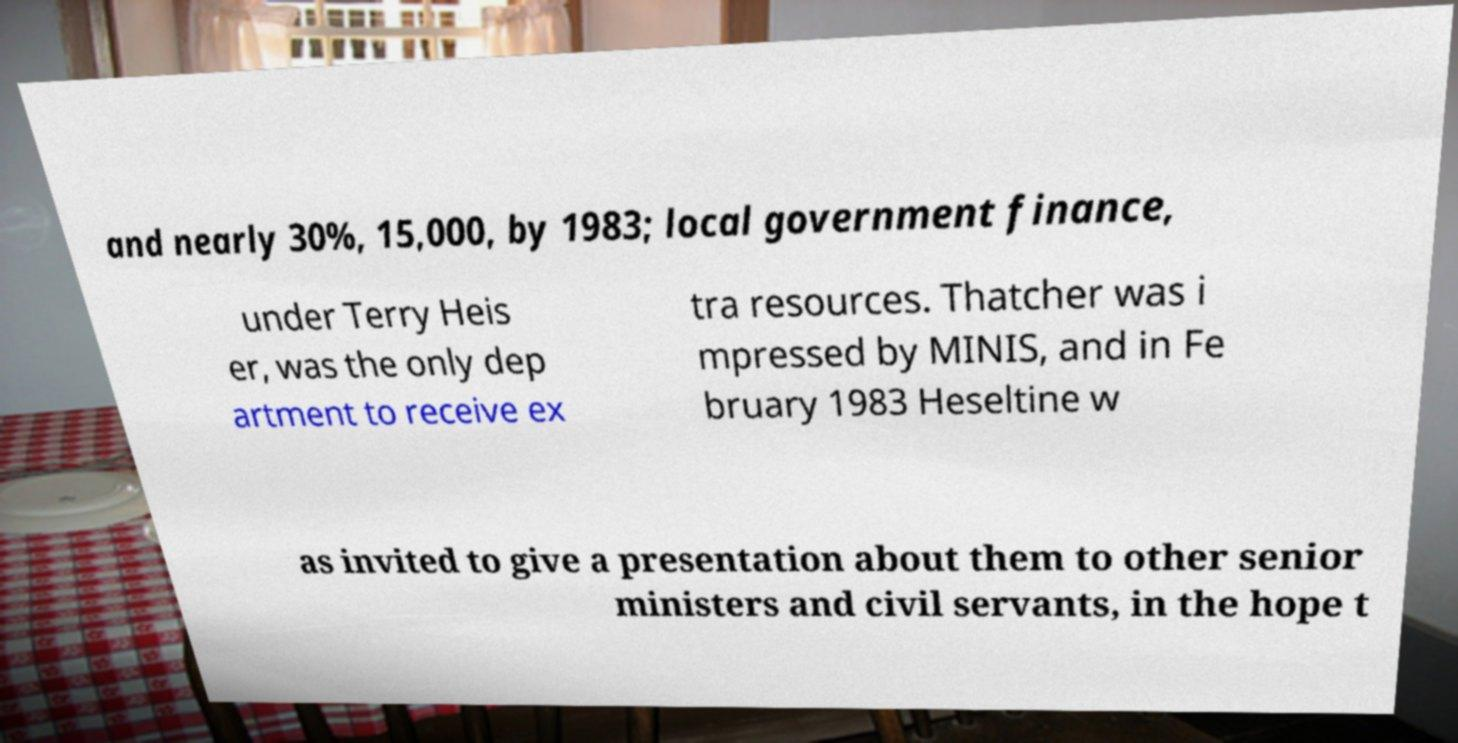Can you read and provide the text displayed in the image?This photo seems to have some interesting text. Can you extract and type it out for me? and nearly 30%, 15,000, by 1983; local government finance, under Terry Heis er, was the only dep artment to receive ex tra resources. Thatcher was i mpressed by MINIS, and in Fe bruary 1983 Heseltine w as invited to give a presentation about them to other senior ministers and civil servants, in the hope t 